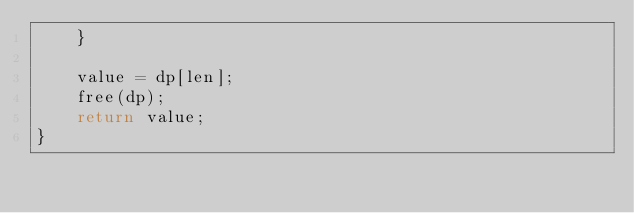<code> <loc_0><loc_0><loc_500><loc_500><_C_>    }

    value = dp[len];
    free(dp);
    return value;
}
</code> 